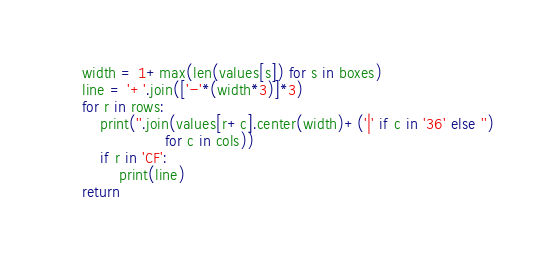Convert code to text. <code><loc_0><loc_0><loc_500><loc_500><_Python_>    width = 1+max(len(values[s]) for s in boxes)
    line = '+'.join(['-'*(width*3)]*3)
    for r in rows:
        print(''.join(values[r+c].center(width)+('|' if c in '36' else '')
                      for c in cols))
        if r in 'CF':
            print(line)
    return
</code> 